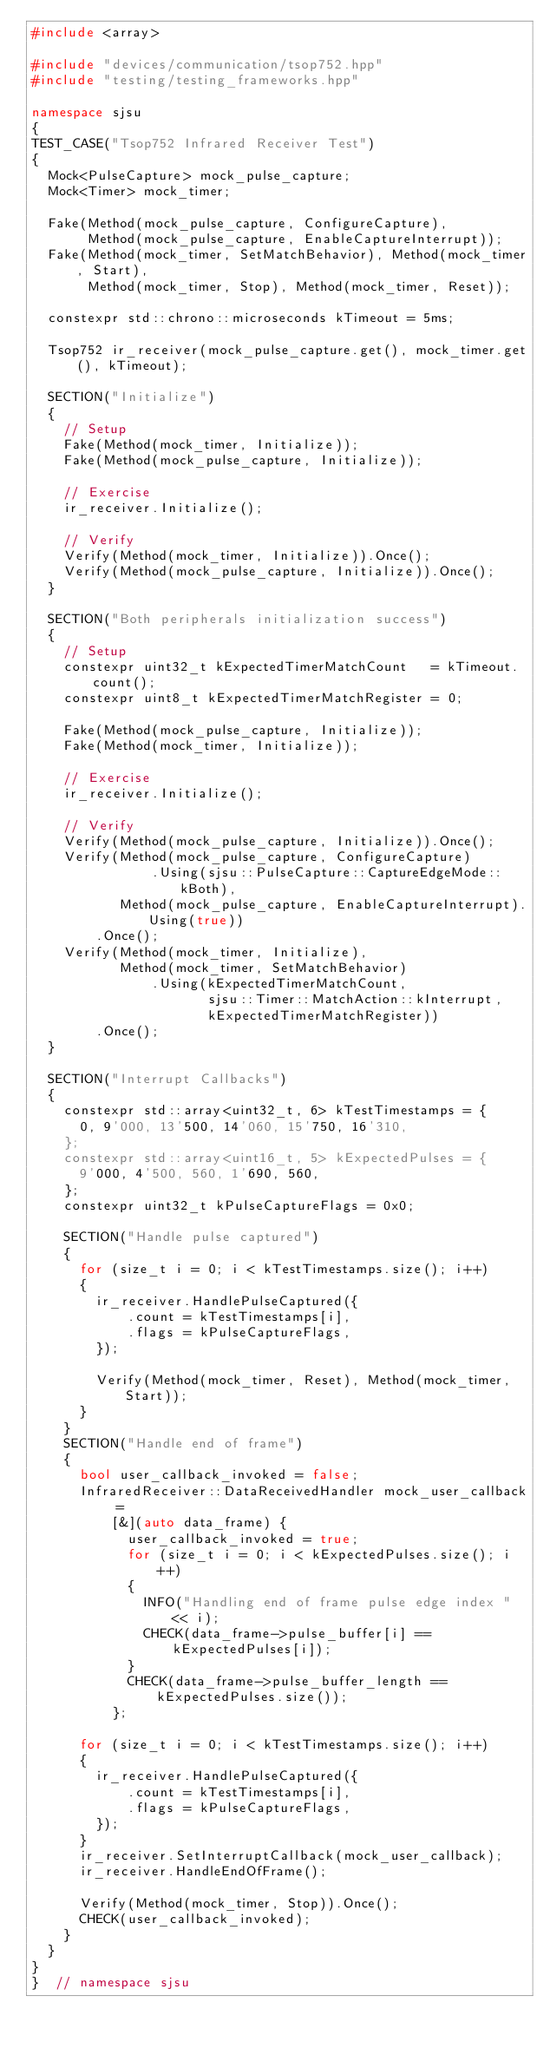<code> <loc_0><loc_0><loc_500><loc_500><_C++_>#include <array>

#include "devices/communication/tsop752.hpp"
#include "testing/testing_frameworks.hpp"

namespace sjsu
{
TEST_CASE("Tsop752 Infrared Receiver Test")
{
  Mock<PulseCapture> mock_pulse_capture;
  Mock<Timer> mock_timer;

  Fake(Method(mock_pulse_capture, ConfigureCapture),
       Method(mock_pulse_capture, EnableCaptureInterrupt));
  Fake(Method(mock_timer, SetMatchBehavior), Method(mock_timer, Start),
       Method(mock_timer, Stop), Method(mock_timer, Reset));

  constexpr std::chrono::microseconds kTimeout = 5ms;

  Tsop752 ir_receiver(mock_pulse_capture.get(), mock_timer.get(), kTimeout);

  SECTION("Initialize")
  {
    // Setup
    Fake(Method(mock_timer, Initialize));
    Fake(Method(mock_pulse_capture, Initialize));

    // Exercise
    ir_receiver.Initialize();

    // Verify
    Verify(Method(mock_timer, Initialize)).Once();
    Verify(Method(mock_pulse_capture, Initialize)).Once();
  }

  SECTION("Both peripherals initialization success")
  {
    // Setup
    constexpr uint32_t kExpectedTimerMatchCount   = kTimeout.count();
    constexpr uint8_t kExpectedTimerMatchRegister = 0;

    Fake(Method(mock_pulse_capture, Initialize));
    Fake(Method(mock_timer, Initialize));

    // Exercise
    ir_receiver.Initialize();

    // Verify
    Verify(Method(mock_pulse_capture, Initialize)).Once();
    Verify(Method(mock_pulse_capture, ConfigureCapture)
               .Using(sjsu::PulseCapture::CaptureEdgeMode::kBoth),
           Method(mock_pulse_capture, EnableCaptureInterrupt).Using(true))
        .Once();
    Verify(Method(mock_timer, Initialize),
           Method(mock_timer, SetMatchBehavior)
               .Using(kExpectedTimerMatchCount,
                      sjsu::Timer::MatchAction::kInterrupt,
                      kExpectedTimerMatchRegister))
        .Once();
  }

  SECTION("Interrupt Callbacks")
  {
    constexpr std::array<uint32_t, 6> kTestTimestamps = {
      0, 9'000, 13'500, 14'060, 15'750, 16'310,
    };
    constexpr std::array<uint16_t, 5> kExpectedPulses = {
      9'000, 4'500, 560, 1'690, 560,
    };
    constexpr uint32_t kPulseCaptureFlags = 0x0;

    SECTION("Handle pulse captured")
    {
      for (size_t i = 0; i < kTestTimestamps.size(); i++)
      {
        ir_receiver.HandlePulseCaptured({
            .count = kTestTimestamps[i],
            .flags = kPulseCaptureFlags,
        });

        Verify(Method(mock_timer, Reset), Method(mock_timer, Start));
      }
    }
    SECTION("Handle end of frame")
    {
      bool user_callback_invoked = false;
      InfraredReceiver::DataReceivedHandler mock_user_callback =
          [&](auto data_frame) {
            user_callback_invoked = true;
            for (size_t i = 0; i < kExpectedPulses.size(); i++)
            {
              INFO("Handling end of frame pulse edge index " << i);
              CHECK(data_frame->pulse_buffer[i] == kExpectedPulses[i]);
            }
            CHECK(data_frame->pulse_buffer_length == kExpectedPulses.size());
          };

      for (size_t i = 0; i < kTestTimestamps.size(); i++)
      {
        ir_receiver.HandlePulseCaptured({
            .count = kTestTimestamps[i],
            .flags = kPulseCaptureFlags,
        });
      }
      ir_receiver.SetInterruptCallback(mock_user_callback);
      ir_receiver.HandleEndOfFrame();

      Verify(Method(mock_timer, Stop)).Once();
      CHECK(user_callback_invoked);
    }
  }
}
}  // namespace sjsu
</code> 